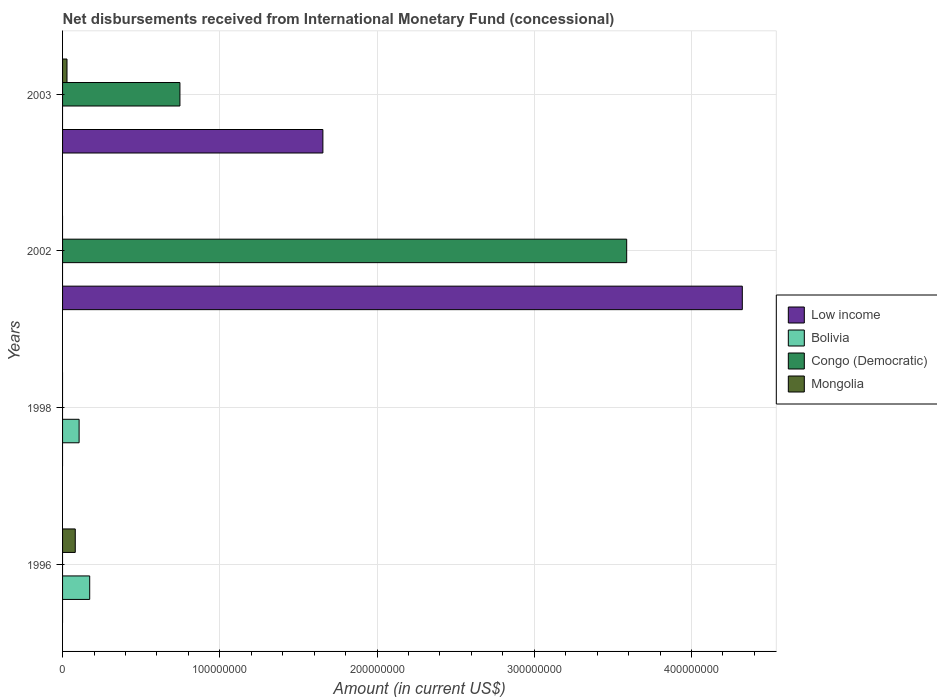Are the number of bars per tick equal to the number of legend labels?
Ensure brevity in your answer.  No. How many bars are there on the 1st tick from the top?
Keep it short and to the point. 3. What is the label of the 4th group of bars from the top?
Your answer should be compact. 1996. In how many cases, is the number of bars for a given year not equal to the number of legend labels?
Provide a short and direct response. 4. What is the amount of disbursements received from International Monetary Fund in Mongolia in 1996?
Your answer should be compact. 8.08e+06. Across all years, what is the maximum amount of disbursements received from International Monetary Fund in Mongolia?
Your response must be concise. 8.08e+06. In which year was the amount of disbursements received from International Monetary Fund in Bolivia maximum?
Give a very brief answer. 1996. What is the total amount of disbursements received from International Monetary Fund in Mongolia in the graph?
Make the answer very short. 1.09e+07. What is the average amount of disbursements received from International Monetary Fund in Bolivia per year?
Offer a very short reply. 6.95e+06. In the year 2003, what is the difference between the amount of disbursements received from International Monetary Fund in Mongolia and amount of disbursements received from International Monetary Fund in Congo (Democratic)?
Your answer should be very brief. -7.18e+07. What is the ratio of the amount of disbursements received from International Monetary Fund in Congo (Democratic) in 2002 to that in 2003?
Offer a very short reply. 4.81. Is the amount of disbursements received from International Monetary Fund in Mongolia in 1996 less than that in 2003?
Make the answer very short. No. What is the difference between the highest and the lowest amount of disbursements received from International Monetary Fund in Congo (Democratic)?
Keep it short and to the point. 3.59e+08. In how many years, is the amount of disbursements received from International Monetary Fund in Bolivia greater than the average amount of disbursements received from International Monetary Fund in Bolivia taken over all years?
Your answer should be very brief. 2. Is the sum of the amount of disbursements received from International Monetary Fund in Congo (Democratic) in 2002 and 2003 greater than the maximum amount of disbursements received from International Monetary Fund in Mongolia across all years?
Your response must be concise. Yes. Is it the case that in every year, the sum of the amount of disbursements received from International Monetary Fund in Low income and amount of disbursements received from International Monetary Fund in Mongolia is greater than the amount of disbursements received from International Monetary Fund in Bolivia?
Ensure brevity in your answer.  No. Are all the bars in the graph horizontal?
Your response must be concise. Yes. How many years are there in the graph?
Make the answer very short. 4. What is the difference between two consecutive major ticks on the X-axis?
Your answer should be compact. 1.00e+08. Are the values on the major ticks of X-axis written in scientific E-notation?
Provide a short and direct response. No. Does the graph contain grids?
Provide a short and direct response. Yes. How are the legend labels stacked?
Ensure brevity in your answer.  Vertical. What is the title of the graph?
Your response must be concise. Net disbursements received from International Monetary Fund (concessional). Does "Cuba" appear as one of the legend labels in the graph?
Keep it short and to the point. No. What is the label or title of the X-axis?
Keep it short and to the point. Amount (in current US$). What is the label or title of the Y-axis?
Provide a short and direct response. Years. What is the Amount (in current US$) in Bolivia in 1996?
Your answer should be very brief. 1.73e+07. What is the Amount (in current US$) of Congo (Democratic) in 1996?
Offer a terse response. 0. What is the Amount (in current US$) in Mongolia in 1996?
Offer a terse response. 8.08e+06. What is the Amount (in current US$) in Bolivia in 1998?
Provide a succinct answer. 1.05e+07. What is the Amount (in current US$) in Congo (Democratic) in 1998?
Make the answer very short. 0. What is the Amount (in current US$) of Mongolia in 1998?
Give a very brief answer. 0. What is the Amount (in current US$) of Low income in 2002?
Give a very brief answer. 4.32e+08. What is the Amount (in current US$) of Bolivia in 2002?
Provide a succinct answer. 0. What is the Amount (in current US$) in Congo (Democratic) in 2002?
Make the answer very short. 3.59e+08. What is the Amount (in current US$) in Low income in 2003?
Provide a short and direct response. 1.66e+08. What is the Amount (in current US$) in Bolivia in 2003?
Keep it short and to the point. 0. What is the Amount (in current US$) in Congo (Democratic) in 2003?
Offer a very short reply. 7.46e+07. What is the Amount (in current US$) of Mongolia in 2003?
Ensure brevity in your answer.  2.82e+06. Across all years, what is the maximum Amount (in current US$) in Low income?
Provide a succinct answer. 4.32e+08. Across all years, what is the maximum Amount (in current US$) in Bolivia?
Your response must be concise. 1.73e+07. Across all years, what is the maximum Amount (in current US$) of Congo (Democratic)?
Your answer should be very brief. 3.59e+08. Across all years, what is the maximum Amount (in current US$) in Mongolia?
Ensure brevity in your answer.  8.08e+06. Across all years, what is the minimum Amount (in current US$) of Bolivia?
Keep it short and to the point. 0. Across all years, what is the minimum Amount (in current US$) in Congo (Democratic)?
Your answer should be compact. 0. Across all years, what is the minimum Amount (in current US$) in Mongolia?
Your answer should be compact. 0. What is the total Amount (in current US$) of Low income in the graph?
Your response must be concise. 5.98e+08. What is the total Amount (in current US$) in Bolivia in the graph?
Offer a very short reply. 2.78e+07. What is the total Amount (in current US$) of Congo (Democratic) in the graph?
Provide a short and direct response. 4.33e+08. What is the total Amount (in current US$) of Mongolia in the graph?
Your response must be concise. 1.09e+07. What is the difference between the Amount (in current US$) in Bolivia in 1996 and that in 1998?
Offer a terse response. 6.75e+06. What is the difference between the Amount (in current US$) of Mongolia in 1996 and that in 2003?
Offer a very short reply. 5.26e+06. What is the difference between the Amount (in current US$) in Low income in 2002 and that in 2003?
Your answer should be compact. 2.67e+08. What is the difference between the Amount (in current US$) of Congo (Democratic) in 2002 and that in 2003?
Make the answer very short. 2.84e+08. What is the difference between the Amount (in current US$) of Bolivia in 1996 and the Amount (in current US$) of Congo (Democratic) in 2002?
Give a very brief answer. -3.42e+08. What is the difference between the Amount (in current US$) of Bolivia in 1996 and the Amount (in current US$) of Congo (Democratic) in 2003?
Your answer should be compact. -5.74e+07. What is the difference between the Amount (in current US$) in Bolivia in 1996 and the Amount (in current US$) in Mongolia in 2003?
Offer a very short reply. 1.44e+07. What is the difference between the Amount (in current US$) in Bolivia in 1998 and the Amount (in current US$) in Congo (Democratic) in 2002?
Your answer should be very brief. -3.48e+08. What is the difference between the Amount (in current US$) in Bolivia in 1998 and the Amount (in current US$) in Congo (Democratic) in 2003?
Provide a short and direct response. -6.41e+07. What is the difference between the Amount (in current US$) in Bolivia in 1998 and the Amount (in current US$) in Mongolia in 2003?
Give a very brief answer. 7.70e+06. What is the difference between the Amount (in current US$) in Low income in 2002 and the Amount (in current US$) in Congo (Democratic) in 2003?
Provide a short and direct response. 3.58e+08. What is the difference between the Amount (in current US$) in Low income in 2002 and the Amount (in current US$) in Mongolia in 2003?
Make the answer very short. 4.30e+08. What is the difference between the Amount (in current US$) in Congo (Democratic) in 2002 and the Amount (in current US$) in Mongolia in 2003?
Your answer should be very brief. 3.56e+08. What is the average Amount (in current US$) in Low income per year?
Give a very brief answer. 1.49e+08. What is the average Amount (in current US$) in Bolivia per year?
Your response must be concise. 6.95e+06. What is the average Amount (in current US$) in Congo (Democratic) per year?
Offer a very short reply. 1.08e+08. What is the average Amount (in current US$) in Mongolia per year?
Your answer should be compact. 2.73e+06. In the year 1996, what is the difference between the Amount (in current US$) in Bolivia and Amount (in current US$) in Mongolia?
Give a very brief answer. 9.19e+06. In the year 2002, what is the difference between the Amount (in current US$) of Low income and Amount (in current US$) of Congo (Democratic)?
Ensure brevity in your answer.  7.35e+07. In the year 2003, what is the difference between the Amount (in current US$) in Low income and Amount (in current US$) in Congo (Democratic)?
Provide a short and direct response. 9.09e+07. In the year 2003, what is the difference between the Amount (in current US$) of Low income and Amount (in current US$) of Mongolia?
Make the answer very short. 1.63e+08. In the year 2003, what is the difference between the Amount (in current US$) in Congo (Democratic) and Amount (in current US$) in Mongolia?
Give a very brief answer. 7.18e+07. What is the ratio of the Amount (in current US$) in Bolivia in 1996 to that in 1998?
Offer a very short reply. 1.64. What is the ratio of the Amount (in current US$) of Mongolia in 1996 to that in 2003?
Provide a short and direct response. 2.86. What is the ratio of the Amount (in current US$) of Low income in 2002 to that in 2003?
Give a very brief answer. 2.61. What is the ratio of the Amount (in current US$) in Congo (Democratic) in 2002 to that in 2003?
Keep it short and to the point. 4.81. What is the difference between the highest and the lowest Amount (in current US$) in Low income?
Make the answer very short. 4.32e+08. What is the difference between the highest and the lowest Amount (in current US$) in Bolivia?
Keep it short and to the point. 1.73e+07. What is the difference between the highest and the lowest Amount (in current US$) of Congo (Democratic)?
Make the answer very short. 3.59e+08. What is the difference between the highest and the lowest Amount (in current US$) in Mongolia?
Your answer should be compact. 8.08e+06. 